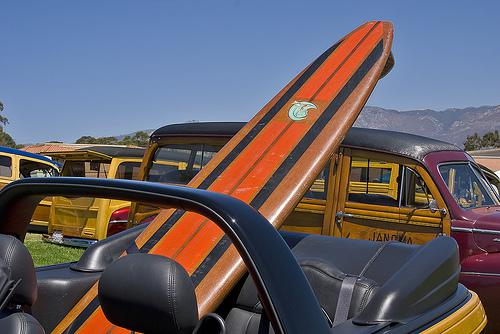Question: what color is the surfboard?
Choices:
A. Orange.
B. Red.
C. White.
D. Blue.
Answer with the letter. Answer: A Question: how many peopleare visible?
Choices:
A. None.
B. 1.
C. 2.
D. 3.
Answer with the letter. Answer: A Question: what is in the photo?
Choices:
A. Bicycles.
B. Cars.
C. Toys.
D. People.
Answer with the letter. Answer: B Question: what is in the background?
Choices:
A. Hills.
B. Horizon.
C. Mountains.
D. Buildings.
Answer with the letter. Answer: C 